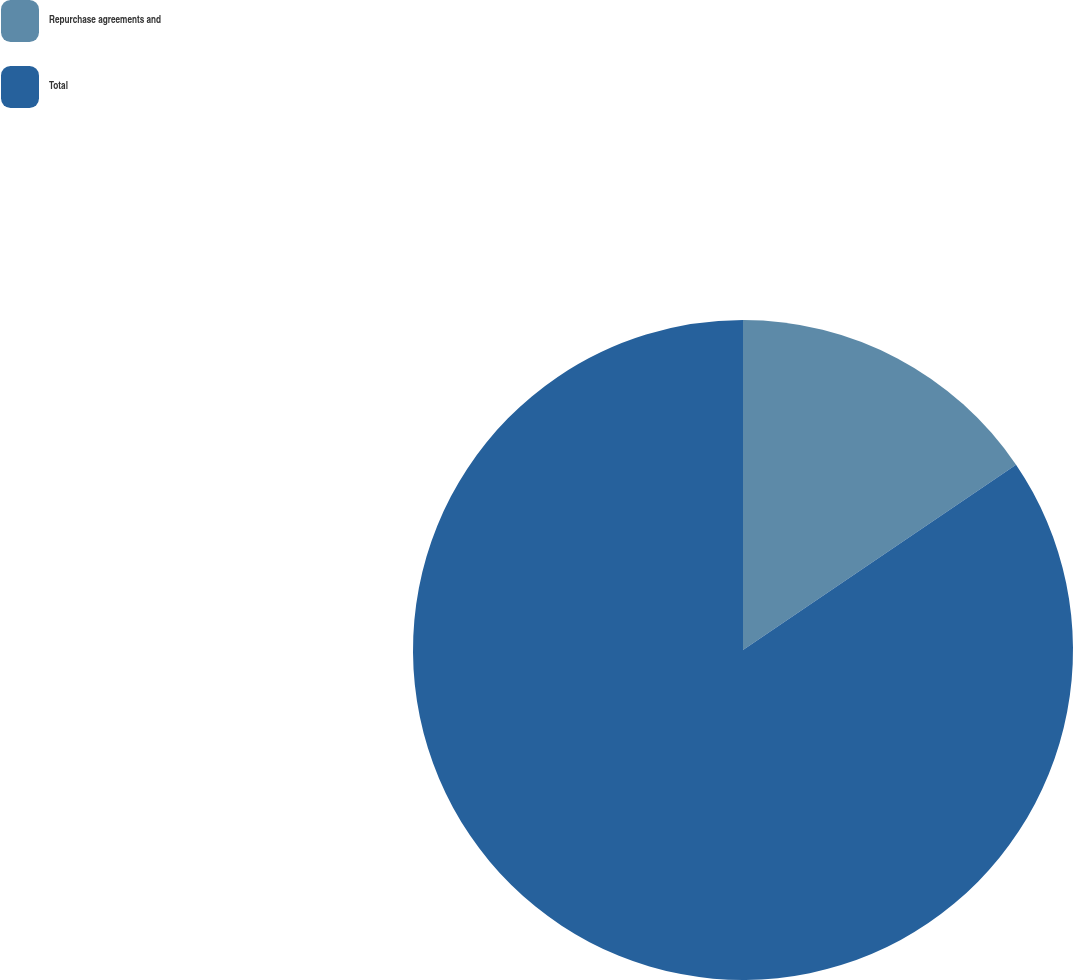Convert chart to OTSL. <chart><loc_0><loc_0><loc_500><loc_500><pie_chart><fcel>Repurchase agreements and<fcel>Total<nl><fcel>15.51%<fcel>84.49%<nl></chart> 